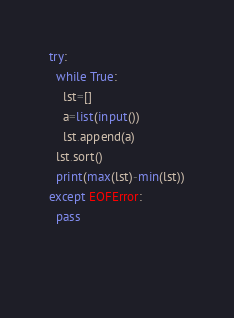Convert code to text. <code><loc_0><loc_0><loc_500><loc_500><_Python_>try:
  while True:
    lst=[]
    a=list(input())
    lst.append(a)
  lst.sort()
  print(max(lst)-min(lst))
except EOFError:
  pass
 
    </code> 